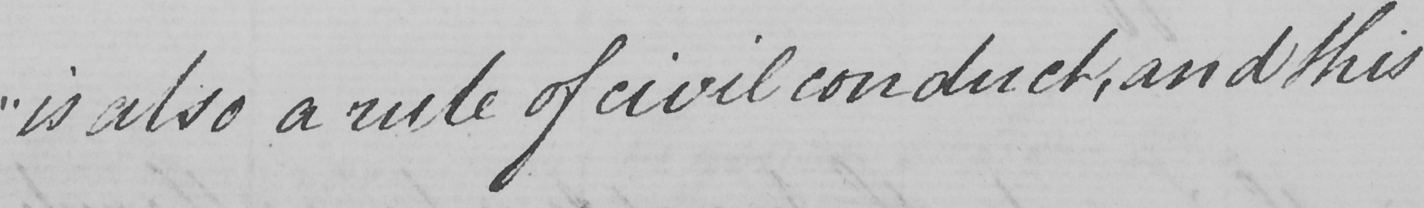Transcribe the text shown in this historical manuscript line. " is also a rule of civil conduct , and this 